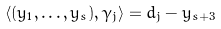<formula> <loc_0><loc_0><loc_500><loc_500>\langle ( y _ { 1 } , \dots , y _ { s } ) , \gamma _ { j } \rangle = d _ { j } - y _ { s + 3 }</formula> 